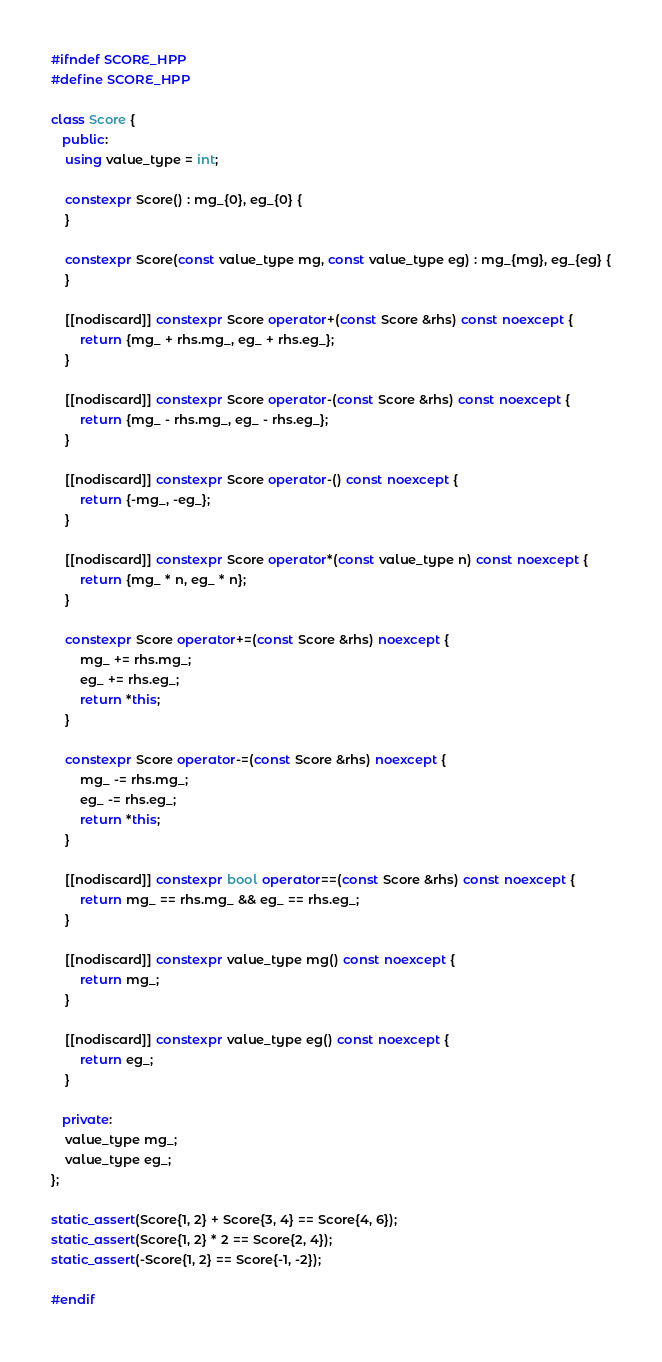Convert code to text. <code><loc_0><loc_0><loc_500><loc_500><_C++_>#ifndef SCORE_HPP
#define SCORE_HPP

class Score {
   public:
    using value_type = int;

    constexpr Score() : mg_{0}, eg_{0} {
    }

    constexpr Score(const value_type mg, const value_type eg) : mg_{mg}, eg_{eg} {
    }

    [[nodiscard]] constexpr Score operator+(const Score &rhs) const noexcept {
        return {mg_ + rhs.mg_, eg_ + rhs.eg_};
    }

    [[nodiscard]] constexpr Score operator-(const Score &rhs) const noexcept {
        return {mg_ - rhs.mg_, eg_ - rhs.eg_};
    }

    [[nodiscard]] constexpr Score operator-() const noexcept {
        return {-mg_, -eg_};
    }

    [[nodiscard]] constexpr Score operator*(const value_type n) const noexcept {
        return {mg_ * n, eg_ * n};
    }

    constexpr Score operator+=(const Score &rhs) noexcept {
        mg_ += rhs.mg_;
        eg_ += rhs.eg_;
        return *this;
    }

    constexpr Score operator-=(const Score &rhs) noexcept {
        mg_ -= rhs.mg_;
        eg_ -= rhs.eg_;
        return *this;
    }

    [[nodiscard]] constexpr bool operator==(const Score &rhs) const noexcept {
        return mg_ == rhs.mg_ && eg_ == rhs.eg_;
    }

    [[nodiscard]] constexpr value_type mg() const noexcept {
        return mg_;
    }

    [[nodiscard]] constexpr value_type eg() const noexcept {
        return eg_;
    }

   private:
    value_type mg_;
    value_type eg_;
};

static_assert(Score{1, 2} + Score{3, 4} == Score{4, 6});
static_assert(Score{1, 2} * 2 == Score{2, 4});
static_assert(-Score{1, 2} == Score{-1, -2});

#endif
</code> 